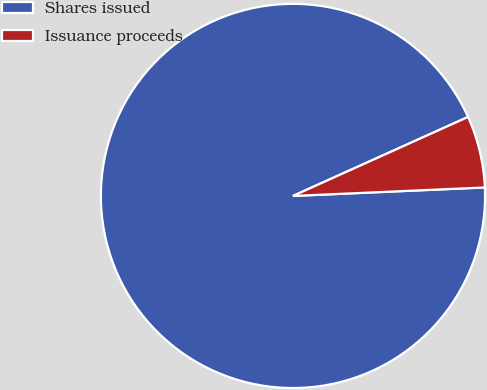Convert chart. <chart><loc_0><loc_0><loc_500><loc_500><pie_chart><fcel>Shares issued<fcel>Issuance proceeds<nl><fcel>93.96%<fcel>6.04%<nl></chart> 